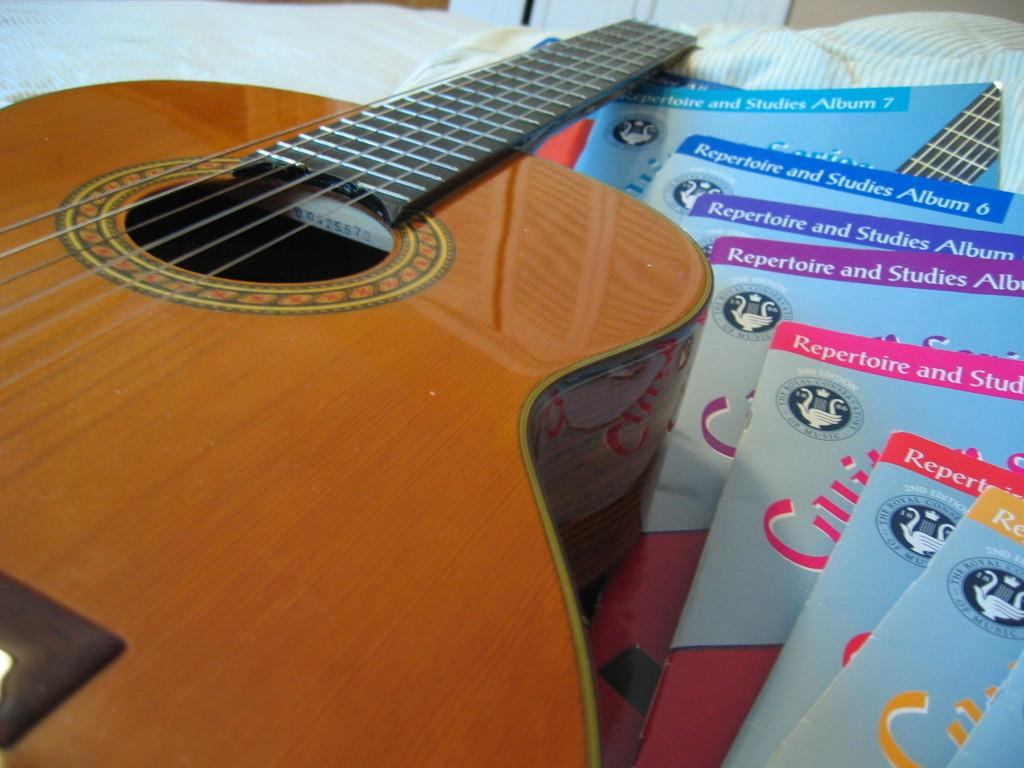What musical instrument is visible in the image? There is a guitar in the image. What other items can be seen near the guitar? There are books present beside the guitar. What is the purpose of the water in the image? There is no water present in the image. What type of beast can be seen interacting with the guitar in the image? There is no beast present in the image; it only features a guitar and books. 